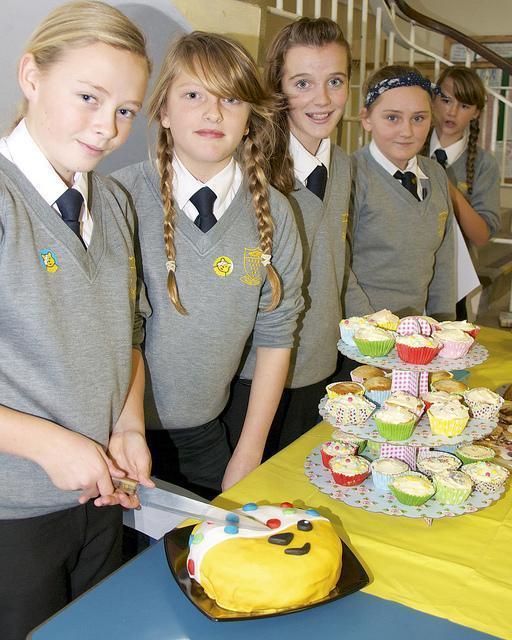How many people can you see?
Give a very brief answer. 5. How many knives are in the photo?
Give a very brief answer. 1. How many cakes can be seen?
Give a very brief answer. 2. 